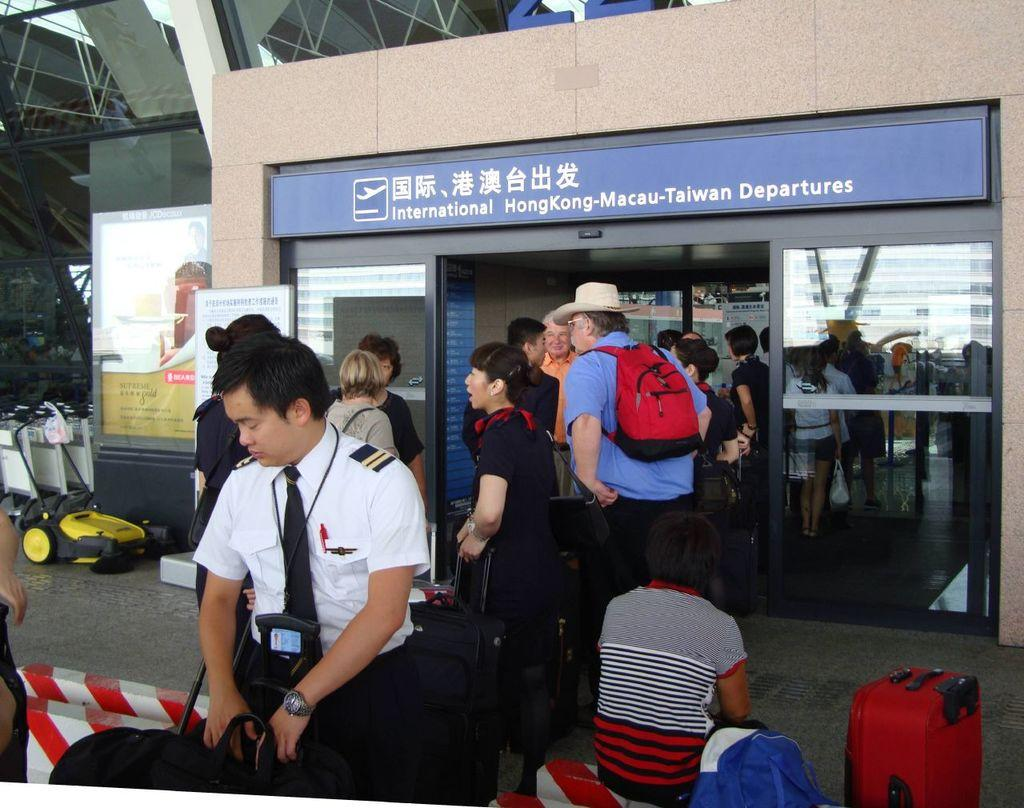What are the people in the image doing with their luggage? The people in the image are carrying luggage. What is the boy in the image doing? The boy is sitting in the image. Where is the scene of the image taking place? The image is set in an airport. What type of tooth can be seen in the boy's hand in the image? There is no tooth present in the image; the boy is sitting and not holding anything. 